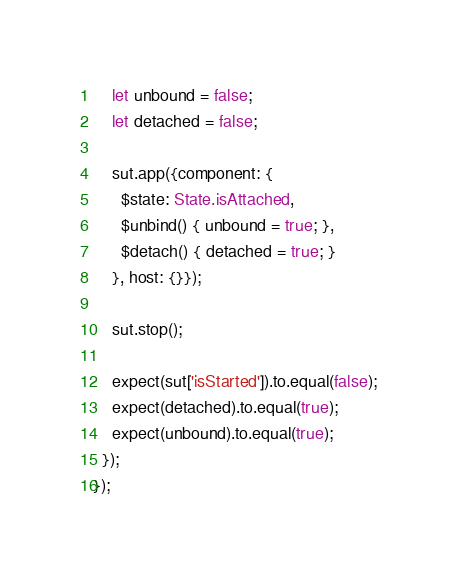Convert code to text. <code><loc_0><loc_0><loc_500><loc_500><_TypeScript_>    let unbound = false;
    let detached = false;

    sut.app({component: {
      $state: State.isAttached,
      $unbind() { unbound = true; },
      $detach() { detached = true; }
    }, host: {}});

    sut.stop();

    expect(sut['isStarted']).to.equal(false);
    expect(detached).to.equal(true);
    expect(unbound).to.equal(true);
  });
});
</code> 